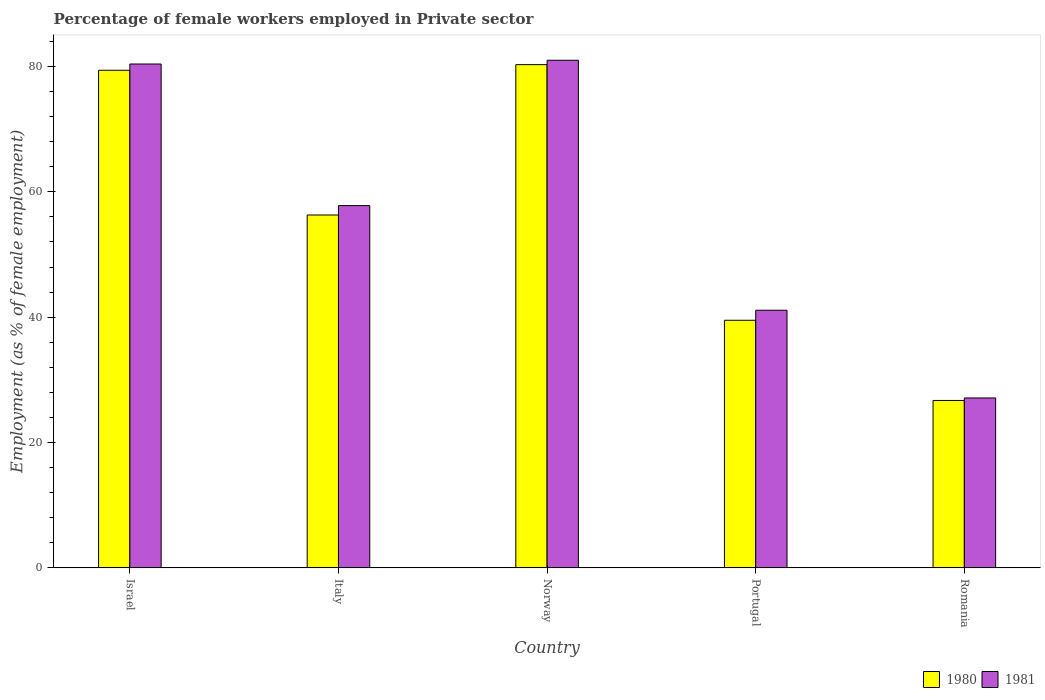How many different coloured bars are there?
Give a very brief answer. 2. How many groups of bars are there?
Keep it short and to the point. 5. Are the number of bars per tick equal to the number of legend labels?
Your answer should be very brief. Yes. What is the label of the 1st group of bars from the left?
Keep it short and to the point. Israel. In how many cases, is the number of bars for a given country not equal to the number of legend labels?
Keep it short and to the point. 0. What is the percentage of females employed in Private sector in 1981 in Italy?
Make the answer very short. 57.8. Across all countries, what is the maximum percentage of females employed in Private sector in 1980?
Keep it short and to the point. 80.3. Across all countries, what is the minimum percentage of females employed in Private sector in 1981?
Make the answer very short. 27.1. In which country was the percentage of females employed in Private sector in 1980 minimum?
Keep it short and to the point. Romania. What is the total percentage of females employed in Private sector in 1981 in the graph?
Your response must be concise. 287.4. What is the difference between the percentage of females employed in Private sector in 1981 in Norway and that in Portugal?
Offer a very short reply. 39.9. What is the difference between the percentage of females employed in Private sector in 1981 in Norway and the percentage of females employed in Private sector in 1980 in Romania?
Your response must be concise. 54.3. What is the average percentage of females employed in Private sector in 1980 per country?
Your answer should be very brief. 56.44. What is the difference between the percentage of females employed in Private sector of/in 1980 and percentage of females employed in Private sector of/in 1981 in Portugal?
Offer a terse response. -1.6. What is the ratio of the percentage of females employed in Private sector in 1980 in Italy to that in Portugal?
Your response must be concise. 1.43. What is the difference between the highest and the second highest percentage of females employed in Private sector in 1980?
Provide a succinct answer. 24. What is the difference between the highest and the lowest percentage of females employed in Private sector in 1980?
Give a very brief answer. 53.6. Is the sum of the percentage of females employed in Private sector in 1981 in Israel and Romania greater than the maximum percentage of females employed in Private sector in 1980 across all countries?
Your answer should be very brief. Yes. What does the 2nd bar from the right in Israel represents?
Offer a terse response. 1980. How many bars are there?
Your response must be concise. 10. Are the values on the major ticks of Y-axis written in scientific E-notation?
Offer a very short reply. No. Does the graph contain grids?
Your answer should be compact. No. Where does the legend appear in the graph?
Provide a short and direct response. Bottom right. What is the title of the graph?
Offer a very short reply. Percentage of female workers employed in Private sector. Does "1983" appear as one of the legend labels in the graph?
Give a very brief answer. No. What is the label or title of the X-axis?
Offer a very short reply. Country. What is the label or title of the Y-axis?
Make the answer very short. Employment (as % of female employment). What is the Employment (as % of female employment) of 1980 in Israel?
Your answer should be very brief. 79.4. What is the Employment (as % of female employment) in 1981 in Israel?
Keep it short and to the point. 80.4. What is the Employment (as % of female employment) of 1980 in Italy?
Make the answer very short. 56.3. What is the Employment (as % of female employment) in 1981 in Italy?
Your answer should be compact. 57.8. What is the Employment (as % of female employment) of 1980 in Norway?
Provide a succinct answer. 80.3. What is the Employment (as % of female employment) of 1981 in Norway?
Provide a succinct answer. 81. What is the Employment (as % of female employment) in 1980 in Portugal?
Provide a succinct answer. 39.5. What is the Employment (as % of female employment) in 1981 in Portugal?
Offer a terse response. 41.1. What is the Employment (as % of female employment) of 1980 in Romania?
Keep it short and to the point. 26.7. What is the Employment (as % of female employment) of 1981 in Romania?
Provide a succinct answer. 27.1. Across all countries, what is the maximum Employment (as % of female employment) in 1980?
Provide a succinct answer. 80.3. Across all countries, what is the minimum Employment (as % of female employment) of 1980?
Give a very brief answer. 26.7. Across all countries, what is the minimum Employment (as % of female employment) in 1981?
Your response must be concise. 27.1. What is the total Employment (as % of female employment) of 1980 in the graph?
Provide a short and direct response. 282.2. What is the total Employment (as % of female employment) of 1981 in the graph?
Give a very brief answer. 287.4. What is the difference between the Employment (as % of female employment) of 1980 in Israel and that in Italy?
Ensure brevity in your answer.  23.1. What is the difference between the Employment (as % of female employment) in 1981 in Israel and that in Italy?
Keep it short and to the point. 22.6. What is the difference between the Employment (as % of female employment) of 1980 in Israel and that in Portugal?
Offer a very short reply. 39.9. What is the difference between the Employment (as % of female employment) in 1981 in Israel and that in Portugal?
Give a very brief answer. 39.3. What is the difference between the Employment (as % of female employment) of 1980 in Israel and that in Romania?
Keep it short and to the point. 52.7. What is the difference between the Employment (as % of female employment) of 1981 in Israel and that in Romania?
Your answer should be compact. 53.3. What is the difference between the Employment (as % of female employment) in 1981 in Italy and that in Norway?
Offer a very short reply. -23.2. What is the difference between the Employment (as % of female employment) in 1980 in Italy and that in Portugal?
Ensure brevity in your answer.  16.8. What is the difference between the Employment (as % of female employment) in 1981 in Italy and that in Portugal?
Ensure brevity in your answer.  16.7. What is the difference between the Employment (as % of female employment) of 1980 in Italy and that in Romania?
Provide a succinct answer. 29.6. What is the difference between the Employment (as % of female employment) of 1981 in Italy and that in Romania?
Provide a succinct answer. 30.7. What is the difference between the Employment (as % of female employment) in 1980 in Norway and that in Portugal?
Offer a very short reply. 40.8. What is the difference between the Employment (as % of female employment) of 1981 in Norway and that in Portugal?
Ensure brevity in your answer.  39.9. What is the difference between the Employment (as % of female employment) in 1980 in Norway and that in Romania?
Your response must be concise. 53.6. What is the difference between the Employment (as % of female employment) in 1981 in Norway and that in Romania?
Your response must be concise. 53.9. What is the difference between the Employment (as % of female employment) in 1980 in Portugal and that in Romania?
Ensure brevity in your answer.  12.8. What is the difference between the Employment (as % of female employment) of 1980 in Israel and the Employment (as % of female employment) of 1981 in Italy?
Your response must be concise. 21.6. What is the difference between the Employment (as % of female employment) in 1980 in Israel and the Employment (as % of female employment) in 1981 in Portugal?
Your answer should be compact. 38.3. What is the difference between the Employment (as % of female employment) of 1980 in Israel and the Employment (as % of female employment) of 1981 in Romania?
Your response must be concise. 52.3. What is the difference between the Employment (as % of female employment) in 1980 in Italy and the Employment (as % of female employment) in 1981 in Norway?
Keep it short and to the point. -24.7. What is the difference between the Employment (as % of female employment) of 1980 in Italy and the Employment (as % of female employment) of 1981 in Romania?
Offer a very short reply. 29.2. What is the difference between the Employment (as % of female employment) of 1980 in Norway and the Employment (as % of female employment) of 1981 in Portugal?
Your response must be concise. 39.2. What is the difference between the Employment (as % of female employment) in 1980 in Norway and the Employment (as % of female employment) in 1981 in Romania?
Keep it short and to the point. 53.2. What is the average Employment (as % of female employment) of 1980 per country?
Keep it short and to the point. 56.44. What is the average Employment (as % of female employment) of 1981 per country?
Provide a short and direct response. 57.48. What is the difference between the Employment (as % of female employment) of 1980 and Employment (as % of female employment) of 1981 in Israel?
Offer a terse response. -1. What is the difference between the Employment (as % of female employment) in 1980 and Employment (as % of female employment) in 1981 in Italy?
Offer a terse response. -1.5. What is the difference between the Employment (as % of female employment) of 1980 and Employment (as % of female employment) of 1981 in Romania?
Ensure brevity in your answer.  -0.4. What is the ratio of the Employment (as % of female employment) in 1980 in Israel to that in Italy?
Provide a succinct answer. 1.41. What is the ratio of the Employment (as % of female employment) in 1981 in Israel to that in Italy?
Offer a very short reply. 1.39. What is the ratio of the Employment (as % of female employment) of 1980 in Israel to that in Portugal?
Ensure brevity in your answer.  2.01. What is the ratio of the Employment (as % of female employment) of 1981 in Israel to that in Portugal?
Your answer should be very brief. 1.96. What is the ratio of the Employment (as % of female employment) in 1980 in Israel to that in Romania?
Ensure brevity in your answer.  2.97. What is the ratio of the Employment (as % of female employment) of 1981 in Israel to that in Romania?
Offer a very short reply. 2.97. What is the ratio of the Employment (as % of female employment) in 1980 in Italy to that in Norway?
Make the answer very short. 0.7. What is the ratio of the Employment (as % of female employment) of 1981 in Italy to that in Norway?
Give a very brief answer. 0.71. What is the ratio of the Employment (as % of female employment) in 1980 in Italy to that in Portugal?
Give a very brief answer. 1.43. What is the ratio of the Employment (as % of female employment) of 1981 in Italy to that in Portugal?
Your answer should be very brief. 1.41. What is the ratio of the Employment (as % of female employment) in 1980 in Italy to that in Romania?
Keep it short and to the point. 2.11. What is the ratio of the Employment (as % of female employment) of 1981 in Italy to that in Romania?
Provide a succinct answer. 2.13. What is the ratio of the Employment (as % of female employment) in 1980 in Norway to that in Portugal?
Your response must be concise. 2.03. What is the ratio of the Employment (as % of female employment) of 1981 in Norway to that in Portugal?
Give a very brief answer. 1.97. What is the ratio of the Employment (as % of female employment) in 1980 in Norway to that in Romania?
Offer a very short reply. 3.01. What is the ratio of the Employment (as % of female employment) in 1981 in Norway to that in Romania?
Ensure brevity in your answer.  2.99. What is the ratio of the Employment (as % of female employment) of 1980 in Portugal to that in Romania?
Offer a very short reply. 1.48. What is the ratio of the Employment (as % of female employment) in 1981 in Portugal to that in Romania?
Make the answer very short. 1.52. What is the difference between the highest and the second highest Employment (as % of female employment) in 1980?
Offer a terse response. 0.9. What is the difference between the highest and the lowest Employment (as % of female employment) in 1980?
Your answer should be compact. 53.6. What is the difference between the highest and the lowest Employment (as % of female employment) of 1981?
Keep it short and to the point. 53.9. 